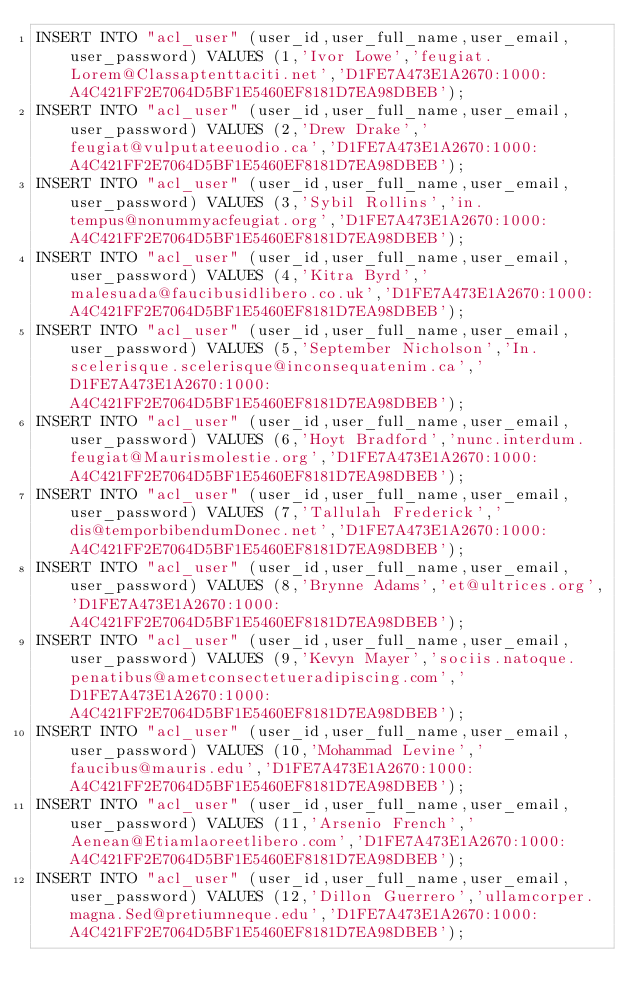Convert code to text. <code><loc_0><loc_0><loc_500><loc_500><_SQL_>INSERT INTO "acl_user" (user_id,user_full_name,user_email,user_password) VALUES (1,'Ivor Lowe','feugiat.Lorem@Classaptenttaciti.net','D1FE7A473E1A2670:1000:A4C421FF2E7064D5BF1E5460EF8181D7EA98DBEB');
INSERT INTO "acl_user" (user_id,user_full_name,user_email,user_password) VALUES (2,'Drew Drake','feugiat@vulputateeuodio.ca','D1FE7A473E1A2670:1000:A4C421FF2E7064D5BF1E5460EF8181D7EA98DBEB');
INSERT INTO "acl_user" (user_id,user_full_name,user_email,user_password) VALUES (3,'Sybil Rollins','in.tempus@nonummyacfeugiat.org','D1FE7A473E1A2670:1000:A4C421FF2E7064D5BF1E5460EF8181D7EA98DBEB');
INSERT INTO "acl_user" (user_id,user_full_name,user_email,user_password) VALUES (4,'Kitra Byrd','malesuada@faucibusidlibero.co.uk','D1FE7A473E1A2670:1000:A4C421FF2E7064D5BF1E5460EF8181D7EA98DBEB');
INSERT INTO "acl_user" (user_id,user_full_name,user_email,user_password) VALUES (5,'September Nicholson','In.scelerisque.scelerisque@inconsequatenim.ca','D1FE7A473E1A2670:1000:A4C421FF2E7064D5BF1E5460EF8181D7EA98DBEB');
INSERT INTO "acl_user" (user_id,user_full_name,user_email,user_password) VALUES (6,'Hoyt Bradford','nunc.interdum.feugiat@Maurismolestie.org','D1FE7A473E1A2670:1000:A4C421FF2E7064D5BF1E5460EF8181D7EA98DBEB');
INSERT INTO "acl_user" (user_id,user_full_name,user_email,user_password) VALUES (7,'Tallulah Frederick','dis@temporbibendumDonec.net','D1FE7A473E1A2670:1000:A4C421FF2E7064D5BF1E5460EF8181D7EA98DBEB');
INSERT INTO "acl_user" (user_id,user_full_name,user_email,user_password) VALUES (8,'Brynne Adams','et@ultrices.org','D1FE7A473E1A2670:1000:A4C421FF2E7064D5BF1E5460EF8181D7EA98DBEB');
INSERT INTO "acl_user" (user_id,user_full_name,user_email,user_password) VALUES (9,'Kevyn Mayer','sociis.natoque.penatibus@ametconsectetueradipiscing.com','D1FE7A473E1A2670:1000:A4C421FF2E7064D5BF1E5460EF8181D7EA98DBEB');
INSERT INTO "acl_user" (user_id,user_full_name,user_email,user_password) VALUES (10,'Mohammad Levine','faucibus@mauris.edu','D1FE7A473E1A2670:1000:A4C421FF2E7064D5BF1E5460EF8181D7EA98DBEB');
INSERT INTO "acl_user" (user_id,user_full_name,user_email,user_password) VALUES (11,'Arsenio French','Aenean@Etiamlaoreetlibero.com','D1FE7A473E1A2670:1000:A4C421FF2E7064D5BF1E5460EF8181D7EA98DBEB');
INSERT INTO "acl_user" (user_id,user_full_name,user_email,user_password) VALUES (12,'Dillon Guerrero','ullamcorper.magna.Sed@pretiumneque.edu','D1FE7A473E1A2670:1000:A4C421FF2E7064D5BF1E5460EF8181D7EA98DBEB');</code> 